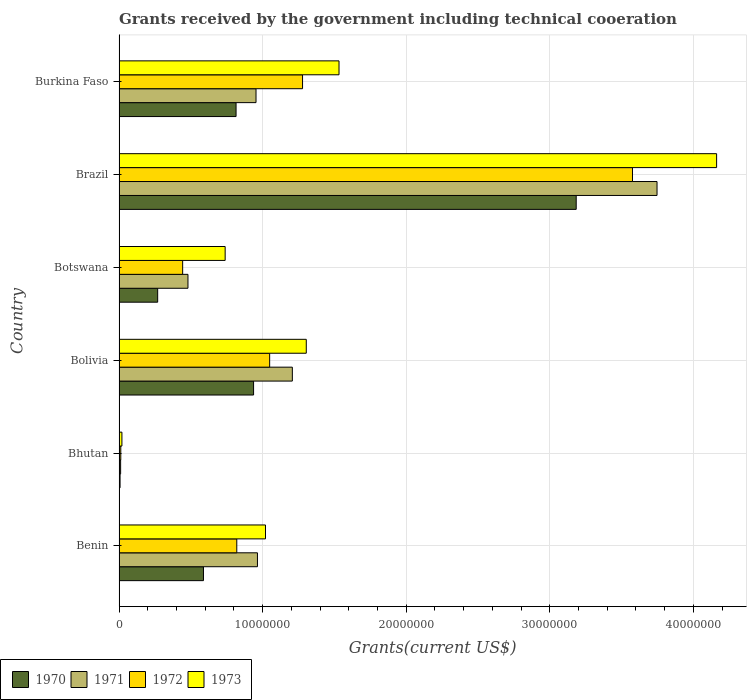How many groups of bars are there?
Your answer should be very brief. 6. Are the number of bars per tick equal to the number of legend labels?
Provide a short and direct response. Yes. Are the number of bars on each tick of the Y-axis equal?
Keep it short and to the point. Yes. What is the label of the 3rd group of bars from the top?
Give a very brief answer. Botswana. In how many cases, is the number of bars for a given country not equal to the number of legend labels?
Ensure brevity in your answer.  0. What is the total grants received by the government in 1970 in Brazil?
Keep it short and to the point. 3.18e+07. Across all countries, what is the maximum total grants received by the government in 1972?
Ensure brevity in your answer.  3.58e+07. In which country was the total grants received by the government in 1971 minimum?
Your answer should be compact. Bhutan. What is the total total grants received by the government in 1971 in the graph?
Offer a very short reply. 7.36e+07. What is the difference between the total grants received by the government in 1970 in Bolivia and that in Burkina Faso?
Ensure brevity in your answer.  1.22e+06. What is the difference between the total grants received by the government in 1973 in Botswana and the total grants received by the government in 1970 in Brazil?
Your response must be concise. -2.44e+07. What is the average total grants received by the government in 1972 per country?
Keep it short and to the point. 1.20e+07. What is the difference between the total grants received by the government in 1971 and total grants received by the government in 1973 in Burkina Faso?
Keep it short and to the point. -5.78e+06. What is the ratio of the total grants received by the government in 1970 in Bhutan to that in Burkina Faso?
Provide a short and direct response. 0.01. Is the difference between the total grants received by the government in 1971 in Benin and Bhutan greater than the difference between the total grants received by the government in 1973 in Benin and Bhutan?
Keep it short and to the point. No. What is the difference between the highest and the second highest total grants received by the government in 1973?
Keep it short and to the point. 2.63e+07. What is the difference between the highest and the lowest total grants received by the government in 1970?
Offer a very short reply. 3.18e+07. In how many countries, is the total grants received by the government in 1973 greater than the average total grants received by the government in 1973 taken over all countries?
Ensure brevity in your answer.  2. Is the sum of the total grants received by the government in 1973 in Bolivia and Burkina Faso greater than the maximum total grants received by the government in 1970 across all countries?
Make the answer very short. No. Is it the case that in every country, the sum of the total grants received by the government in 1970 and total grants received by the government in 1972 is greater than the total grants received by the government in 1973?
Make the answer very short. No. How many bars are there?
Offer a very short reply. 24. What is the difference between two consecutive major ticks on the X-axis?
Your answer should be compact. 1.00e+07. Are the values on the major ticks of X-axis written in scientific E-notation?
Your answer should be compact. No. Does the graph contain grids?
Your answer should be very brief. Yes. What is the title of the graph?
Keep it short and to the point. Grants received by the government including technical cooeration. Does "1995" appear as one of the legend labels in the graph?
Give a very brief answer. No. What is the label or title of the X-axis?
Give a very brief answer. Grants(current US$). What is the Grants(current US$) of 1970 in Benin?
Keep it short and to the point. 5.88e+06. What is the Grants(current US$) of 1971 in Benin?
Give a very brief answer. 9.64e+06. What is the Grants(current US$) in 1972 in Benin?
Your answer should be compact. 8.20e+06. What is the Grants(current US$) in 1973 in Benin?
Give a very brief answer. 1.02e+07. What is the Grants(current US$) of 1970 in Bhutan?
Your answer should be very brief. 7.00e+04. What is the Grants(current US$) in 1971 in Bhutan?
Provide a succinct answer. 1.10e+05. What is the Grants(current US$) in 1970 in Bolivia?
Make the answer very short. 9.37e+06. What is the Grants(current US$) of 1971 in Bolivia?
Make the answer very short. 1.21e+07. What is the Grants(current US$) in 1972 in Bolivia?
Ensure brevity in your answer.  1.05e+07. What is the Grants(current US$) of 1973 in Bolivia?
Make the answer very short. 1.30e+07. What is the Grants(current US$) in 1970 in Botswana?
Give a very brief answer. 2.69e+06. What is the Grants(current US$) in 1971 in Botswana?
Give a very brief answer. 4.80e+06. What is the Grants(current US$) of 1972 in Botswana?
Provide a short and direct response. 4.43e+06. What is the Grants(current US$) in 1973 in Botswana?
Provide a short and direct response. 7.39e+06. What is the Grants(current US$) of 1970 in Brazil?
Ensure brevity in your answer.  3.18e+07. What is the Grants(current US$) in 1971 in Brazil?
Your answer should be very brief. 3.75e+07. What is the Grants(current US$) in 1972 in Brazil?
Provide a short and direct response. 3.58e+07. What is the Grants(current US$) of 1973 in Brazil?
Make the answer very short. 4.16e+07. What is the Grants(current US$) of 1970 in Burkina Faso?
Make the answer very short. 8.15e+06. What is the Grants(current US$) in 1971 in Burkina Faso?
Ensure brevity in your answer.  9.54e+06. What is the Grants(current US$) of 1972 in Burkina Faso?
Make the answer very short. 1.28e+07. What is the Grants(current US$) in 1973 in Burkina Faso?
Provide a succinct answer. 1.53e+07. Across all countries, what is the maximum Grants(current US$) of 1970?
Offer a very short reply. 3.18e+07. Across all countries, what is the maximum Grants(current US$) in 1971?
Provide a succinct answer. 3.75e+07. Across all countries, what is the maximum Grants(current US$) of 1972?
Keep it short and to the point. 3.58e+07. Across all countries, what is the maximum Grants(current US$) of 1973?
Your answer should be very brief. 4.16e+07. Across all countries, what is the minimum Grants(current US$) in 1970?
Make the answer very short. 7.00e+04. Across all countries, what is the minimum Grants(current US$) in 1971?
Your response must be concise. 1.10e+05. Across all countries, what is the minimum Grants(current US$) in 1972?
Provide a short and direct response. 1.20e+05. Across all countries, what is the minimum Grants(current US$) in 1973?
Provide a succinct answer. 2.00e+05. What is the total Grants(current US$) of 1970 in the graph?
Your response must be concise. 5.80e+07. What is the total Grants(current US$) in 1971 in the graph?
Your answer should be very brief. 7.36e+07. What is the total Grants(current US$) in 1972 in the graph?
Provide a short and direct response. 7.18e+07. What is the total Grants(current US$) of 1973 in the graph?
Provide a succinct answer. 8.78e+07. What is the difference between the Grants(current US$) of 1970 in Benin and that in Bhutan?
Ensure brevity in your answer.  5.81e+06. What is the difference between the Grants(current US$) of 1971 in Benin and that in Bhutan?
Offer a very short reply. 9.53e+06. What is the difference between the Grants(current US$) in 1972 in Benin and that in Bhutan?
Offer a terse response. 8.08e+06. What is the difference between the Grants(current US$) in 1973 in Benin and that in Bhutan?
Ensure brevity in your answer.  1.00e+07. What is the difference between the Grants(current US$) in 1970 in Benin and that in Bolivia?
Ensure brevity in your answer.  -3.49e+06. What is the difference between the Grants(current US$) of 1971 in Benin and that in Bolivia?
Ensure brevity in your answer.  -2.43e+06. What is the difference between the Grants(current US$) in 1972 in Benin and that in Bolivia?
Your response must be concise. -2.29e+06. What is the difference between the Grants(current US$) in 1973 in Benin and that in Bolivia?
Ensure brevity in your answer.  -2.84e+06. What is the difference between the Grants(current US$) of 1970 in Benin and that in Botswana?
Provide a short and direct response. 3.19e+06. What is the difference between the Grants(current US$) in 1971 in Benin and that in Botswana?
Make the answer very short. 4.84e+06. What is the difference between the Grants(current US$) of 1972 in Benin and that in Botswana?
Your answer should be compact. 3.77e+06. What is the difference between the Grants(current US$) in 1973 in Benin and that in Botswana?
Your response must be concise. 2.81e+06. What is the difference between the Grants(current US$) of 1970 in Benin and that in Brazil?
Your response must be concise. -2.60e+07. What is the difference between the Grants(current US$) in 1971 in Benin and that in Brazil?
Ensure brevity in your answer.  -2.78e+07. What is the difference between the Grants(current US$) in 1972 in Benin and that in Brazil?
Your answer should be compact. -2.76e+07. What is the difference between the Grants(current US$) of 1973 in Benin and that in Brazil?
Ensure brevity in your answer.  -3.14e+07. What is the difference between the Grants(current US$) in 1970 in Benin and that in Burkina Faso?
Ensure brevity in your answer.  -2.27e+06. What is the difference between the Grants(current US$) in 1972 in Benin and that in Burkina Faso?
Make the answer very short. -4.58e+06. What is the difference between the Grants(current US$) in 1973 in Benin and that in Burkina Faso?
Your response must be concise. -5.12e+06. What is the difference between the Grants(current US$) in 1970 in Bhutan and that in Bolivia?
Your answer should be very brief. -9.30e+06. What is the difference between the Grants(current US$) of 1971 in Bhutan and that in Bolivia?
Offer a very short reply. -1.20e+07. What is the difference between the Grants(current US$) of 1972 in Bhutan and that in Bolivia?
Offer a very short reply. -1.04e+07. What is the difference between the Grants(current US$) of 1973 in Bhutan and that in Bolivia?
Provide a succinct answer. -1.28e+07. What is the difference between the Grants(current US$) in 1970 in Bhutan and that in Botswana?
Provide a succinct answer. -2.62e+06. What is the difference between the Grants(current US$) in 1971 in Bhutan and that in Botswana?
Ensure brevity in your answer.  -4.69e+06. What is the difference between the Grants(current US$) in 1972 in Bhutan and that in Botswana?
Your answer should be very brief. -4.31e+06. What is the difference between the Grants(current US$) of 1973 in Bhutan and that in Botswana?
Your answer should be very brief. -7.19e+06. What is the difference between the Grants(current US$) in 1970 in Bhutan and that in Brazil?
Provide a succinct answer. -3.18e+07. What is the difference between the Grants(current US$) of 1971 in Bhutan and that in Brazil?
Your answer should be compact. -3.74e+07. What is the difference between the Grants(current US$) in 1972 in Bhutan and that in Brazil?
Offer a very short reply. -3.56e+07. What is the difference between the Grants(current US$) of 1973 in Bhutan and that in Brazil?
Provide a succinct answer. -4.14e+07. What is the difference between the Grants(current US$) of 1970 in Bhutan and that in Burkina Faso?
Ensure brevity in your answer.  -8.08e+06. What is the difference between the Grants(current US$) in 1971 in Bhutan and that in Burkina Faso?
Your answer should be compact. -9.43e+06. What is the difference between the Grants(current US$) in 1972 in Bhutan and that in Burkina Faso?
Give a very brief answer. -1.27e+07. What is the difference between the Grants(current US$) in 1973 in Bhutan and that in Burkina Faso?
Your answer should be very brief. -1.51e+07. What is the difference between the Grants(current US$) in 1970 in Bolivia and that in Botswana?
Your answer should be very brief. 6.68e+06. What is the difference between the Grants(current US$) of 1971 in Bolivia and that in Botswana?
Make the answer very short. 7.27e+06. What is the difference between the Grants(current US$) in 1972 in Bolivia and that in Botswana?
Keep it short and to the point. 6.06e+06. What is the difference between the Grants(current US$) in 1973 in Bolivia and that in Botswana?
Ensure brevity in your answer.  5.65e+06. What is the difference between the Grants(current US$) of 1970 in Bolivia and that in Brazil?
Offer a very short reply. -2.25e+07. What is the difference between the Grants(current US$) in 1971 in Bolivia and that in Brazil?
Ensure brevity in your answer.  -2.54e+07. What is the difference between the Grants(current US$) of 1972 in Bolivia and that in Brazil?
Ensure brevity in your answer.  -2.53e+07. What is the difference between the Grants(current US$) in 1973 in Bolivia and that in Brazil?
Your response must be concise. -2.86e+07. What is the difference between the Grants(current US$) in 1970 in Bolivia and that in Burkina Faso?
Your answer should be very brief. 1.22e+06. What is the difference between the Grants(current US$) in 1971 in Bolivia and that in Burkina Faso?
Give a very brief answer. 2.53e+06. What is the difference between the Grants(current US$) in 1972 in Bolivia and that in Burkina Faso?
Your response must be concise. -2.29e+06. What is the difference between the Grants(current US$) in 1973 in Bolivia and that in Burkina Faso?
Make the answer very short. -2.28e+06. What is the difference between the Grants(current US$) of 1970 in Botswana and that in Brazil?
Provide a short and direct response. -2.92e+07. What is the difference between the Grants(current US$) of 1971 in Botswana and that in Brazil?
Provide a short and direct response. -3.27e+07. What is the difference between the Grants(current US$) of 1972 in Botswana and that in Brazil?
Provide a short and direct response. -3.13e+07. What is the difference between the Grants(current US$) of 1973 in Botswana and that in Brazil?
Provide a short and direct response. -3.42e+07. What is the difference between the Grants(current US$) of 1970 in Botswana and that in Burkina Faso?
Provide a succinct answer. -5.46e+06. What is the difference between the Grants(current US$) in 1971 in Botswana and that in Burkina Faso?
Your answer should be very brief. -4.74e+06. What is the difference between the Grants(current US$) of 1972 in Botswana and that in Burkina Faso?
Your answer should be very brief. -8.35e+06. What is the difference between the Grants(current US$) of 1973 in Botswana and that in Burkina Faso?
Ensure brevity in your answer.  -7.93e+06. What is the difference between the Grants(current US$) in 1970 in Brazil and that in Burkina Faso?
Make the answer very short. 2.37e+07. What is the difference between the Grants(current US$) in 1971 in Brazil and that in Burkina Faso?
Provide a short and direct response. 2.79e+07. What is the difference between the Grants(current US$) of 1972 in Brazil and that in Burkina Faso?
Offer a very short reply. 2.30e+07. What is the difference between the Grants(current US$) in 1973 in Brazil and that in Burkina Faso?
Your answer should be compact. 2.63e+07. What is the difference between the Grants(current US$) in 1970 in Benin and the Grants(current US$) in 1971 in Bhutan?
Ensure brevity in your answer.  5.77e+06. What is the difference between the Grants(current US$) of 1970 in Benin and the Grants(current US$) of 1972 in Bhutan?
Keep it short and to the point. 5.76e+06. What is the difference between the Grants(current US$) in 1970 in Benin and the Grants(current US$) in 1973 in Bhutan?
Offer a terse response. 5.68e+06. What is the difference between the Grants(current US$) of 1971 in Benin and the Grants(current US$) of 1972 in Bhutan?
Give a very brief answer. 9.52e+06. What is the difference between the Grants(current US$) of 1971 in Benin and the Grants(current US$) of 1973 in Bhutan?
Offer a very short reply. 9.44e+06. What is the difference between the Grants(current US$) in 1972 in Benin and the Grants(current US$) in 1973 in Bhutan?
Give a very brief answer. 8.00e+06. What is the difference between the Grants(current US$) in 1970 in Benin and the Grants(current US$) in 1971 in Bolivia?
Ensure brevity in your answer.  -6.19e+06. What is the difference between the Grants(current US$) in 1970 in Benin and the Grants(current US$) in 1972 in Bolivia?
Provide a short and direct response. -4.61e+06. What is the difference between the Grants(current US$) in 1970 in Benin and the Grants(current US$) in 1973 in Bolivia?
Keep it short and to the point. -7.16e+06. What is the difference between the Grants(current US$) of 1971 in Benin and the Grants(current US$) of 1972 in Bolivia?
Provide a succinct answer. -8.50e+05. What is the difference between the Grants(current US$) of 1971 in Benin and the Grants(current US$) of 1973 in Bolivia?
Make the answer very short. -3.40e+06. What is the difference between the Grants(current US$) in 1972 in Benin and the Grants(current US$) in 1973 in Bolivia?
Keep it short and to the point. -4.84e+06. What is the difference between the Grants(current US$) in 1970 in Benin and the Grants(current US$) in 1971 in Botswana?
Make the answer very short. 1.08e+06. What is the difference between the Grants(current US$) of 1970 in Benin and the Grants(current US$) of 1972 in Botswana?
Your answer should be compact. 1.45e+06. What is the difference between the Grants(current US$) in 1970 in Benin and the Grants(current US$) in 1973 in Botswana?
Keep it short and to the point. -1.51e+06. What is the difference between the Grants(current US$) in 1971 in Benin and the Grants(current US$) in 1972 in Botswana?
Offer a terse response. 5.21e+06. What is the difference between the Grants(current US$) of 1971 in Benin and the Grants(current US$) of 1973 in Botswana?
Your answer should be very brief. 2.25e+06. What is the difference between the Grants(current US$) of 1972 in Benin and the Grants(current US$) of 1973 in Botswana?
Keep it short and to the point. 8.10e+05. What is the difference between the Grants(current US$) of 1970 in Benin and the Grants(current US$) of 1971 in Brazil?
Your answer should be compact. -3.16e+07. What is the difference between the Grants(current US$) of 1970 in Benin and the Grants(current US$) of 1972 in Brazil?
Your response must be concise. -2.99e+07. What is the difference between the Grants(current US$) in 1970 in Benin and the Grants(current US$) in 1973 in Brazil?
Offer a terse response. -3.57e+07. What is the difference between the Grants(current US$) of 1971 in Benin and the Grants(current US$) of 1972 in Brazil?
Your answer should be compact. -2.61e+07. What is the difference between the Grants(current US$) of 1971 in Benin and the Grants(current US$) of 1973 in Brazil?
Make the answer very short. -3.20e+07. What is the difference between the Grants(current US$) in 1972 in Benin and the Grants(current US$) in 1973 in Brazil?
Offer a very short reply. -3.34e+07. What is the difference between the Grants(current US$) in 1970 in Benin and the Grants(current US$) in 1971 in Burkina Faso?
Provide a short and direct response. -3.66e+06. What is the difference between the Grants(current US$) in 1970 in Benin and the Grants(current US$) in 1972 in Burkina Faso?
Provide a short and direct response. -6.90e+06. What is the difference between the Grants(current US$) of 1970 in Benin and the Grants(current US$) of 1973 in Burkina Faso?
Provide a succinct answer. -9.44e+06. What is the difference between the Grants(current US$) of 1971 in Benin and the Grants(current US$) of 1972 in Burkina Faso?
Your response must be concise. -3.14e+06. What is the difference between the Grants(current US$) in 1971 in Benin and the Grants(current US$) in 1973 in Burkina Faso?
Provide a succinct answer. -5.68e+06. What is the difference between the Grants(current US$) in 1972 in Benin and the Grants(current US$) in 1973 in Burkina Faso?
Offer a terse response. -7.12e+06. What is the difference between the Grants(current US$) in 1970 in Bhutan and the Grants(current US$) in 1971 in Bolivia?
Offer a terse response. -1.20e+07. What is the difference between the Grants(current US$) in 1970 in Bhutan and the Grants(current US$) in 1972 in Bolivia?
Your answer should be very brief. -1.04e+07. What is the difference between the Grants(current US$) of 1970 in Bhutan and the Grants(current US$) of 1973 in Bolivia?
Offer a very short reply. -1.30e+07. What is the difference between the Grants(current US$) of 1971 in Bhutan and the Grants(current US$) of 1972 in Bolivia?
Your response must be concise. -1.04e+07. What is the difference between the Grants(current US$) in 1971 in Bhutan and the Grants(current US$) in 1973 in Bolivia?
Make the answer very short. -1.29e+07. What is the difference between the Grants(current US$) of 1972 in Bhutan and the Grants(current US$) of 1973 in Bolivia?
Provide a short and direct response. -1.29e+07. What is the difference between the Grants(current US$) of 1970 in Bhutan and the Grants(current US$) of 1971 in Botswana?
Offer a terse response. -4.73e+06. What is the difference between the Grants(current US$) in 1970 in Bhutan and the Grants(current US$) in 1972 in Botswana?
Provide a succinct answer. -4.36e+06. What is the difference between the Grants(current US$) in 1970 in Bhutan and the Grants(current US$) in 1973 in Botswana?
Keep it short and to the point. -7.32e+06. What is the difference between the Grants(current US$) of 1971 in Bhutan and the Grants(current US$) of 1972 in Botswana?
Offer a very short reply. -4.32e+06. What is the difference between the Grants(current US$) of 1971 in Bhutan and the Grants(current US$) of 1973 in Botswana?
Offer a terse response. -7.28e+06. What is the difference between the Grants(current US$) in 1972 in Bhutan and the Grants(current US$) in 1973 in Botswana?
Keep it short and to the point. -7.27e+06. What is the difference between the Grants(current US$) of 1970 in Bhutan and the Grants(current US$) of 1971 in Brazil?
Provide a short and direct response. -3.74e+07. What is the difference between the Grants(current US$) of 1970 in Bhutan and the Grants(current US$) of 1972 in Brazil?
Ensure brevity in your answer.  -3.57e+07. What is the difference between the Grants(current US$) in 1970 in Bhutan and the Grants(current US$) in 1973 in Brazil?
Your answer should be compact. -4.16e+07. What is the difference between the Grants(current US$) of 1971 in Bhutan and the Grants(current US$) of 1972 in Brazil?
Your response must be concise. -3.56e+07. What is the difference between the Grants(current US$) in 1971 in Bhutan and the Grants(current US$) in 1973 in Brazil?
Your answer should be very brief. -4.15e+07. What is the difference between the Grants(current US$) of 1972 in Bhutan and the Grants(current US$) of 1973 in Brazil?
Keep it short and to the point. -4.15e+07. What is the difference between the Grants(current US$) in 1970 in Bhutan and the Grants(current US$) in 1971 in Burkina Faso?
Ensure brevity in your answer.  -9.47e+06. What is the difference between the Grants(current US$) in 1970 in Bhutan and the Grants(current US$) in 1972 in Burkina Faso?
Your response must be concise. -1.27e+07. What is the difference between the Grants(current US$) in 1970 in Bhutan and the Grants(current US$) in 1973 in Burkina Faso?
Keep it short and to the point. -1.52e+07. What is the difference between the Grants(current US$) in 1971 in Bhutan and the Grants(current US$) in 1972 in Burkina Faso?
Keep it short and to the point. -1.27e+07. What is the difference between the Grants(current US$) in 1971 in Bhutan and the Grants(current US$) in 1973 in Burkina Faso?
Keep it short and to the point. -1.52e+07. What is the difference between the Grants(current US$) in 1972 in Bhutan and the Grants(current US$) in 1973 in Burkina Faso?
Keep it short and to the point. -1.52e+07. What is the difference between the Grants(current US$) of 1970 in Bolivia and the Grants(current US$) of 1971 in Botswana?
Offer a terse response. 4.57e+06. What is the difference between the Grants(current US$) in 1970 in Bolivia and the Grants(current US$) in 1972 in Botswana?
Provide a short and direct response. 4.94e+06. What is the difference between the Grants(current US$) of 1970 in Bolivia and the Grants(current US$) of 1973 in Botswana?
Keep it short and to the point. 1.98e+06. What is the difference between the Grants(current US$) of 1971 in Bolivia and the Grants(current US$) of 1972 in Botswana?
Your answer should be very brief. 7.64e+06. What is the difference between the Grants(current US$) of 1971 in Bolivia and the Grants(current US$) of 1973 in Botswana?
Provide a short and direct response. 4.68e+06. What is the difference between the Grants(current US$) of 1972 in Bolivia and the Grants(current US$) of 1973 in Botswana?
Your answer should be compact. 3.10e+06. What is the difference between the Grants(current US$) in 1970 in Bolivia and the Grants(current US$) in 1971 in Brazil?
Provide a short and direct response. -2.81e+07. What is the difference between the Grants(current US$) in 1970 in Bolivia and the Grants(current US$) in 1972 in Brazil?
Offer a very short reply. -2.64e+07. What is the difference between the Grants(current US$) of 1970 in Bolivia and the Grants(current US$) of 1973 in Brazil?
Keep it short and to the point. -3.22e+07. What is the difference between the Grants(current US$) in 1971 in Bolivia and the Grants(current US$) in 1972 in Brazil?
Offer a terse response. -2.37e+07. What is the difference between the Grants(current US$) of 1971 in Bolivia and the Grants(current US$) of 1973 in Brazil?
Your answer should be very brief. -2.96e+07. What is the difference between the Grants(current US$) in 1972 in Bolivia and the Grants(current US$) in 1973 in Brazil?
Provide a short and direct response. -3.11e+07. What is the difference between the Grants(current US$) in 1970 in Bolivia and the Grants(current US$) in 1971 in Burkina Faso?
Ensure brevity in your answer.  -1.70e+05. What is the difference between the Grants(current US$) of 1970 in Bolivia and the Grants(current US$) of 1972 in Burkina Faso?
Your response must be concise. -3.41e+06. What is the difference between the Grants(current US$) in 1970 in Bolivia and the Grants(current US$) in 1973 in Burkina Faso?
Your answer should be very brief. -5.95e+06. What is the difference between the Grants(current US$) of 1971 in Bolivia and the Grants(current US$) of 1972 in Burkina Faso?
Ensure brevity in your answer.  -7.10e+05. What is the difference between the Grants(current US$) of 1971 in Bolivia and the Grants(current US$) of 1973 in Burkina Faso?
Offer a terse response. -3.25e+06. What is the difference between the Grants(current US$) of 1972 in Bolivia and the Grants(current US$) of 1973 in Burkina Faso?
Ensure brevity in your answer.  -4.83e+06. What is the difference between the Grants(current US$) of 1970 in Botswana and the Grants(current US$) of 1971 in Brazil?
Ensure brevity in your answer.  -3.48e+07. What is the difference between the Grants(current US$) in 1970 in Botswana and the Grants(current US$) in 1972 in Brazil?
Offer a terse response. -3.31e+07. What is the difference between the Grants(current US$) in 1970 in Botswana and the Grants(current US$) in 1973 in Brazil?
Provide a succinct answer. -3.89e+07. What is the difference between the Grants(current US$) of 1971 in Botswana and the Grants(current US$) of 1972 in Brazil?
Keep it short and to the point. -3.10e+07. What is the difference between the Grants(current US$) of 1971 in Botswana and the Grants(current US$) of 1973 in Brazil?
Your answer should be very brief. -3.68e+07. What is the difference between the Grants(current US$) in 1972 in Botswana and the Grants(current US$) in 1973 in Brazil?
Provide a succinct answer. -3.72e+07. What is the difference between the Grants(current US$) in 1970 in Botswana and the Grants(current US$) in 1971 in Burkina Faso?
Your answer should be compact. -6.85e+06. What is the difference between the Grants(current US$) of 1970 in Botswana and the Grants(current US$) of 1972 in Burkina Faso?
Ensure brevity in your answer.  -1.01e+07. What is the difference between the Grants(current US$) in 1970 in Botswana and the Grants(current US$) in 1973 in Burkina Faso?
Offer a terse response. -1.26e+07. What is the difference between the Grants(current US$) in 1971 in Botswana and the Grants(current US$) in 1972 in Burkina Faso?
Give a very brief answer. -7.98e+06. What is the difference between the Grants(current US$) of 1971 in Botswana and the Grants(current US$) of 1973 in Burkina Faso?
Provide a succinct answer. -1.05e+07. What is the difference between the Grants(current US$) of 1972 in Botswana and the Grants(current US$) of 1973 in Burkina Faso?
Your response must be concise. -1.09e+07. What is the difference between the Grants(current US$) of 1970 in Brazil and the Grants(current US$) of 1971 in Burkina Faso?
Make the answer very short. 2.23e+07. What is the difference between the Grants(current US$) of 1970 in Brazil and the Grants(current US$) of 1972 in Burkina Faso?
Provide a succinct answer. 1.91e+07. What is the difference between the Grants(current US$) in 1970 in Brazil and the Grants(current US$) in 1973 in Burkina Faso?
Offer a very short reply. 1.65e+07. What is the difference between the Grants(current US$) in 1971 in Brazil and the Grants(current US$) in 1972 in Burkina Faso?
Keep it short and to the point. 2.47e+07. What is the difference between the Grants(current US$) of 1971 in Brazil and the Grants(current US$) of 1973 in Burkina Faso?
Keep it short and to the point. 2.22e+07. What is the difference between the Grants(current US$) in 1972 in Brazil and the Grants(current US$) in 1973 in Burkina Faso?
Provide a short and direct response. 2.04e+07. What is the average Grants(current US$) of 1970 per country?
Give a very brief answer. 9.67e+06. What is the average Grants(current US$) in 1971 per country?
Offer a terse response. 1.23e+07. What is the average Grants(current US$) of 1972 per country?
Offer a very short reply. 1.20e+07. What is the average Grants(current US$) in 1973 per country?
Provide a succinct answer. 1.46e+07. What is the difference between the Grants(current US$) of 1970 and Grants(current US$) of 1971 in Benin?
Offer a very short reply. -3.76e+06. What is the difference between the Grants(current US$) of 1970 and Grants(current US$) of 1972 in Benin?
Keep it short and to the point. -2.32e+06. What is the difference between the Grants(current US$) in 1970 and Grants(current US$) in 1973 in Benin?
Your answer should be compact. -4.32e+06. What is the difference between the Grants(current US$) in 1971 and Grants(current US$) in 1972 in Benin?
Keep it short and to the point. 1.44e+06. What is the difference between the Grants(current US$) in 1971 and Grants(current US$) in 1973 in Benin?
Offer a very short reply. -5.60e+05. What is the difference between the Grants(current US$) in 1972 and Grants(current US$) in 1973 in Benin?
Your response must be concise. -2.00e+06. What is the difference between the Grants(current US$) of 1970 and Grants(current US$) of 1971 in Bhutan?
Make the answer very short. -4.00e+04. What is the difference between the Grants(current US$) in 1971 and Grants(current US$) in 1973 in Bhutan?
Provide a short and direct response. -9.00e+04. What is the difference between the Grants(current US$) of 1972 and Grants(current US$) of 1973 in Bhutan?
Provide a short and direct response. -8.00e+04. What is the difference between the Grants(current US$) of 1970 and Grants(current US$) of 1971 in Bolivia?
Provide a short and direct response. -2.70e+06. What is the difference between the Grants(current US$) in 1970 and Grants(current US$) in 1972 in Bolivia?
Your answer should be very brief. -1.12e+06. What is the difference between the Grants(current US$) in 1970 and Grants(current US$) in 1973 in Bolivia?
Your answer should be very brief. -3.67e+06. What is the difference between the Grants(current US$) in 1971 and Grants(current US$) in 1972 in Bolivia?
Keep it short and to the point. 1.58e+06. What is the difference between the Grants(current US$) in 1971 and Grants(current US$) in 1973 in Bolivia?
Make the answer very short. -9.70e+05. What is the difference between the Grants(current US$) of 1972 and Grants(current US$) of 1973 in Bolivia?
Offer a terse response. -2.55e+06. What is the difference between the Grants(current US$) in 1970 and Grants(current US$) in 1971 in Botswana?
Your answer should be compact. -2.11e+06. What is the difference between the Grants(current US$) of 1970 and Grants(current US$) of 1972 in Botswana?
Your response must be concise. -1.74e+06. What is the difference between the Grants(current US$) of 1970 and Grants(current US$) of 1973 in Botswana?
Your response must be concise. -4.70e+06. What is the difference between the Grants(current US$) of 1971 and Grants(current US$) of 1973 in Botswana?
Keep it short and to the point. -2.59e+06. What is the difference between the Grants(current US$) of 1972 and Grants(current US$) of 1973 in Botswana?
Ensure brevity in your answer.  -2.96e+06. What is the difference between the Grants(current US$) in 1970 and Grants(current US$) in 1971 in Brazil?
Your answer should be very brief. -5.63e+06. What is the difference between the Grants(current US$) in 1970 and Grants(current US$) in 1972 in Brazil?
Your response must be concise. -3.92e+06. What is the difference between the Grants(current US$) in 1970 and Grants(current US$) in 1973 in Brazil?
Give a very brief answer. -9.78e+06. What is the difference between the Grants(current US$) in 1971 and Grants(current US$) in 1972 in Brazil?
Your answer should be compact. 1.71e+06. What is the difference between the Grants(current US$) of 1971 and Grants(current US$) of 1973 in Brazil?
Your answer should be very brief. -4.15e+06. What is the difference between the Grants(current US$) of 1972 and Grants(current US$) of 1973 in Brazil?
Make the answer very short. -5.86e+06. What is the difference between the Grants(current US$) in 1970 and Grants(current US$) in 1971 in Burkina Faso?
Your answer should be very brief. -1.39e+06. What is the difference between the Grants(current US$) of 1970 and Grants(current US$) of 1972 in Burkina Faso?
Give a very brief answer. -4.63e+06. What is the difference between the Grants(current US$) of 1970 and Grants(current US$) of 1973 in Burkina Faso?
Your answer should be very brief. -7.17e+06. What is the difference between the Grants(current US$) in 1971 and Grants(current US$) in 1972 in Burkina Faso?
Your answer should be very brief. -3.24e+06. What is the difference between the Grants(current US$) in 1971 and Grants(current US$) in 1973 in Burkina Faso?
Offer a very short reply. -5.78e+06. What is the difference between the Grants(current US$) of 1972 and Grants(current US$) of 1973 in Burkina Faso?
Keep it short and to the point. -2.54e+06. What is the ratio of the Grants(current US$) in 1970 in Benin to that in Bhutan?
Provide a succinct answer. 84. What is the ratio of the Grants(current US$) of 1971 in Benin to that in Bhutan?
Provide a short and direct response. 87.64. What is the ratio of the Grants(current US$) in 1972 in Benin to that in Bhutan?
Your answer should be compact. 68.33. What is the ratio of the Grants(current US$) of 1973 in Benin to that in Bhutan?
Give a very brief answer. 51. What is the ratio of the Grants(current US$) of 1970 in Benin to that in Bolivia?
Your answer should be very brief. 0.63. What is the ratio of the Grants(current US$) in 1971 in Benin to that in Bolivia?
Your response must be concise. 0.8. What is the ratio of the Grants(current US$) in 1972 in Benin to that in Bolivia?
Give a very brief answer. 0.78. What is the ratio of the Grants(current US$) of 1973 in Benin to that in Bolivia?
Your response must be concise. 0.78. What is the ratio of the Grants(current US$) of 1970 in Benin to that in Botswana?
Keep it short and to the point. 2.19. What is the ratio of the Grants(current US$) in 1971 in Benin to that in Botswana?
Ensure brevity in your answer.  2.01. What is the ratio of the Grants(current US$) of 1972 in Benin to that in Botswana?
Your answer should be compact. 1.85. What is the ratio of the Grants(current US$) of 1973 in Benin to that in Botswana?
Provide a short and direct response. 1.38. What is the ratio of the Grants(current US$) in 1970 in Benin to that in Brazil?
Offer a terse response. 0.18. What is the ratio of the Grants(current US$) of 1971 in Benin to that in Brazil?
Provide a succinct answer. 0.26. What is the ratio of the Grants(current US$) in 1972 in Benin to that in Brazil?
Ensure brevity in your answer.  0.23. What is the ratio of the Grants(current US$) of 1973 in Benin to that in Brazil?
Offer a very short reply. 0.25. What is the ratio of the Grants(current US$) of 1970 in Benin to that in Burkina Faso?
Offer a very short reply. 0.72. What is the ratio of the Grants(current US$) of 1971 in Benin to that in Burkina Faso?
Offer a very short reply. 1.01. What is the ratio of the Grants(current US$) in 1972 in Benin to that in Burkina Faso?
Offer a very short reply. 0.64. What is the ratio of the Grants(current US$) of 1973 in Benin to that in Burkina Faso?
Your response must be concise. 0.67. What is the ratio of the Grants(current US$) of 1970 in Bhutan to that in Bolivia?
Your answer should be very brief. 0.01. What is the ratio of the Grants(current US$) in 1971 in Bhutan to that in Bolivia?
Give a very brief answer. 0.01. What is the ratio of the Grants(current US$) in 1972 in Bhutan to that in Bolivia?
Offer a very short reply. 0.01. What is the ratio of the Grants(current US$) of 1973 in Bhutan to that in Bolivia?
Your response must be concise. 0.02. What is the ratio of the Grants(current US$) in 1970 in Bhutan to that in Botswana?
Your response must be concise. 0.03. What is the ratio of the Grants(current US$) of 1971 in Bhutan to that in Botswana?
Your answer should be very brief. 0.02. What is the ratio of the Grants(current US$) of 1972 in Bhutan to that in Botswana?
Your answer should be compact. 0.03. What is the ratio of the Grants(current US$) in 1973 in Bhutan to that in Botswana?
Your answer should be compact. 0.03. What is the ratio of the Grants(current US$) of 1970 in Bhutan to that in Brazil?
Offer a terse response. 0. What is the ratio of the Grants(current US$) of 1971 in Bhutan to that in Brazil?
Your answer should be very brief. 0. What is the ratio of the Grants(current US$) in 1972 in Bhutan to that in Brazil?
Your answer should be compact. 0. What is the ratio of the Grants(current US$) in 1973 in Bhutan to that in Brazil?
Your answer should be compact. 0. What is the ratio of the Grants(current US$) in 1970 in Bhutan to that in Burkina Faso?
Ensure brevity in your answer.  0.01. What is the ratio of the Grants(current US$) in 1971 in Bhutan to that in Burkina Faso?
Make the answer very short. 0.01. What is the ratio of the Grants(current US$) in 1972 in Bhutan to that in Burkina Faso?
Provide a succinct answer. 0.01. What is the ratio of the Grants(current US$) in 1973 in Bhutan to that in Burkina Faso?
Ensure brevity in your answer.  0.01. What is the ratio of the Grants(current US$) in 1970 in Bolivia to that in Botswana?
Provide a succinct answer. 3.48. What is the ratio of the Grants(current US$) in 1971 in Bolivia to that in Botswana?
Your answer should be compact. 2.51. What is the ratio of the Grants(current US$) of 1972 in Bolivia to that in Botswana?
Provide a short and direct response. 2.37. What is the ratio of the Grants(current US$) in 1973 in Bolivia to that in Botswana?
Ensure brevity in your answer.  1.76. What is the ratio of the Grants(current US$) in 1970 in Bolivia to that in Brazil?
Provide a short and direct response. 0.29. What is the ratio of the Grants(current US$) in 1971 in Bolivia to that in Brazil?
Offer a terse response. 0.32. What is the ratio of the Grants(current US$) in 1972 in Bolivia to that in Brazil?
Give a very brief answer. 0.29. What is the ratio of the Grants(current US$) in 1973 in Bolivia to that in Brazil?
Your response must be concise. 0.31. What is the ratio of the Grants(current US$) in 1970 in Bolivia to that in Burkina Faso?
Provide a short and direct response. 1.15. What is the ratio of the Grants(current US$) in 1971 in Bolivia to that in Burkina Faso?
Keep it short and to the point. 1.27. What is the ratio of the Grants(current US$) of 1972 in Bolivia to that in Burkina Faso?
Your answer should be very brief. 0.82. What is the ratio of the Grants(current US$) in 1973 in Bolivia to that in Burkina Faso?
Your response must be concise. 0.85. What is the ratio of the Grants(current US$) in 1970 in Botswana to that in Brazil?
Provide a succinct answer. 0.08. What is the ratio of the Grants(current US$) in 1971 in Botswana to that in Brazil?
Provide a succinct answer. 0.13. What is the ratio of the Grants(current US$) in 1972 in Botswana to that in Brazil?
Keep it short and to the point. 0.12. What is the ratio of the Grants(current US$) of 1973 in Botswana to that in Brazil?
Make the answer very short. 0.18. What is the ratio of the Grants(current US$) of 1970 in Botswana to that in Burkina Faso?
Provide a short and direct response. 0.33. What is the ratio of the Grants(current US$) of 1971 in Botswana to that in Burkina Faso?
Your response must be concise. 0.5. What is the ratio of the Grants(current US$) in 1972 in Botswana to that in Burkina Faso?
Your response must be concise. 0.35. What is the ratio of the Grants(current US$) of 1973 in Botswana to that in Burkina Faso?
Offer a very short reply. 0.48. What is the ratio of the Grants(current US$) of 1970 in Brazil to that in Burkina Faso?
Offer a very short reply. 3.91. What is the ratio of the Grants(current US$) in 1971 in Brazil to that in Burkina Faso?
Ensure brevity in your answer.  3.93. What is the ratio of the Grants(current US$) of 1972 in Brazil to that in Burkina Faso?
Your response must be concise. 2.8. What is the ratio of the Grants(current US$) of 1973 in Brazil to that in Burkina Faso?
Your answer should be compact. 2.72. What is the difference between the highest and the second highest Grants(current US$) of 1970?
Your answer should be very brief. 2.25e+07. What is the difference between the highest and the second highest Grants(current US$) in 1971?
Ensure brevity in your answer.  2.54e+07. What is the difference between the highest and the second highest Grants(current US$) in 1972?
Your answer should be compact. 2.30e+07. What is the difference between the highest and the second highest Grants(current US$) in 1973?
Your response must be concise. 2.63e+07. What is the difference between the highest and the lowest Grants(current US$) in 1970?
Give a very brief answer. 3.18e+07. What is the difference between the highest and the lowest Grants(current US$) in 1971?
Offer a terse response. 3.74e+07. What is the difference between the highest and the lowest Grants(current US$) in 1972?
Ensure brevity in your answer.  3.56e+07. What is the difference between the highest and the lowest Grants(current US$) of 1973?
Make the answer very short. 4.14e+07. 